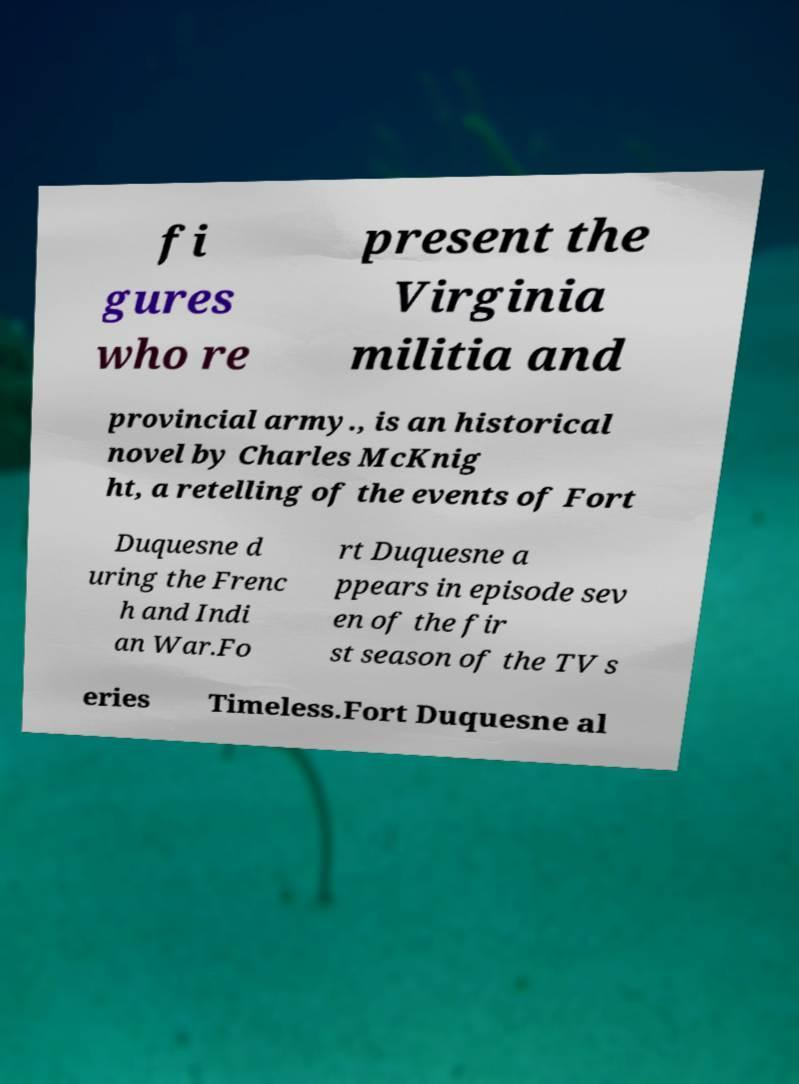What messages or text are displayed in this image? I need them in a readable, typed format. fi gures who re present the Virginia militia and provincial army., is an historical novel by Charles McKnig ht, a retelling of the events of Fort Duquesne d uring the Frenc h and Indi an War.Fo rt Duquesne a ppears in episode sev en of the fir st season of the TV s eries Timeless.Fort Duquesne al 